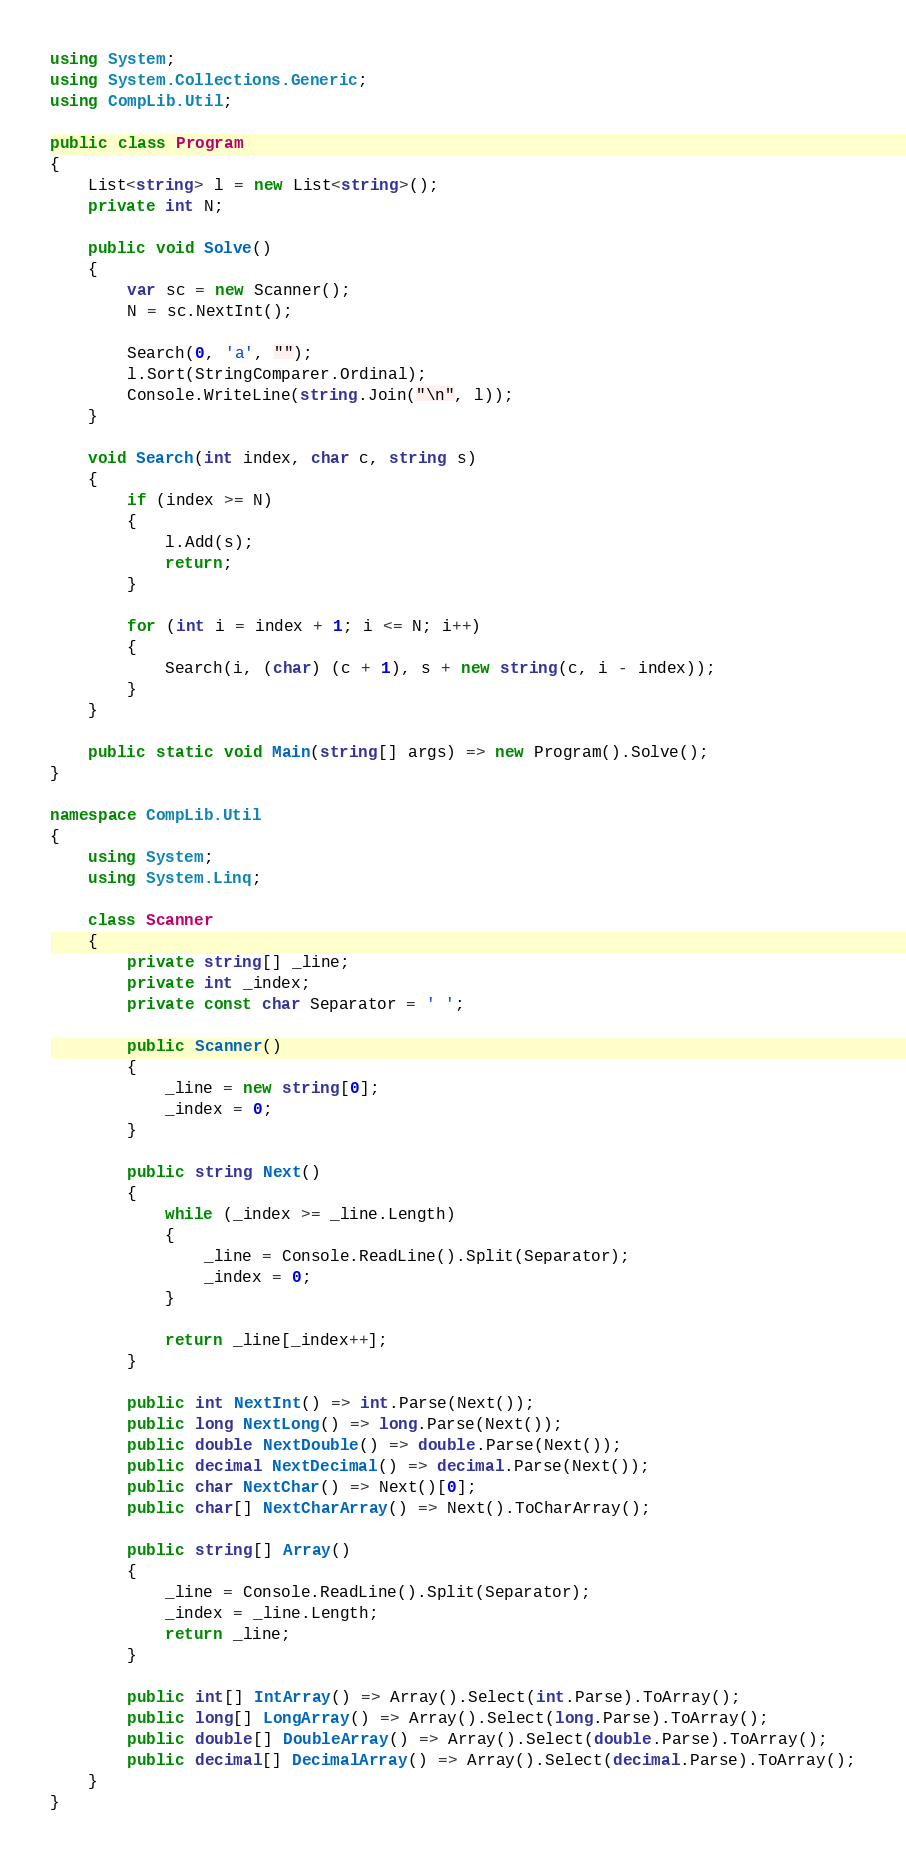<code> <loc_0><loc_0><loc_500><loc_500><_C#_>using System;
using System.Collections.Generic;
using CompLib.Util;

public class Program
{
    List<string> l = new List<string>();
    private int N;

    public void Solve()
    {
        var sc = new Scanner();
        N = sc.NextInt();

        Search(0, 'a', "");
        l.Sort(StringComparer.Ordinal);
        Console.WriteLine(string.Join("\n", l));
    }

    void Search(int index, char c, string s)
    {
        if (index >= N)
        {
            l.Add(s);
            return;
        }

        for (int i = index + 1; i <= N; i++)
        {
            Search(i, (char) (c + 1), s + new string(c, i - index));
        }
    }

    public static void Main(string[] args) => new Program().Solve();
}

namespace CompLib.Util
{
    using System;
    using System.Linq;

    class Scanner
    {
        private string[] _line;
        private int _index;
        private const char Separator = ' ';

        public Scanner()
        {
            _line = new string[0];
            _index = 0;
        }

        public string Next()
        {
            while (_index >= _line.Length)
            {
                _line = Console.ReadLine().Split(Separator);
                _index = 0;
            }

            return _line[_index++];
        }

        public int NextInt() => int.Parse(Next());
        public long NextLong() => long.Parse(Next());
        public double NextDouble() => double.Parse(Next());
        public decimal NextDecimal() => decimal.Parse(Next());
        public char NextChar() => Next()[0];
        public char[] NextCharArray() => Next().ToCharArray();

        public string[] Array()
        {
            _line = Console.ReadLine().Split(Separator);
            _index = _line.Length;
            return _line;
        }

        public int[] IntArray() => Array().Select(int.Parse).ToArray();
        public long[] LongArray() => Array().Select(long.Parse).ToArray();
        public double[] DoubleArray() => Array().Select(double.Parse).ToArray();
        public decimal[] DecimalArray() => Array().Select(decimal.Parse).ToArray();
    }
}</code> 